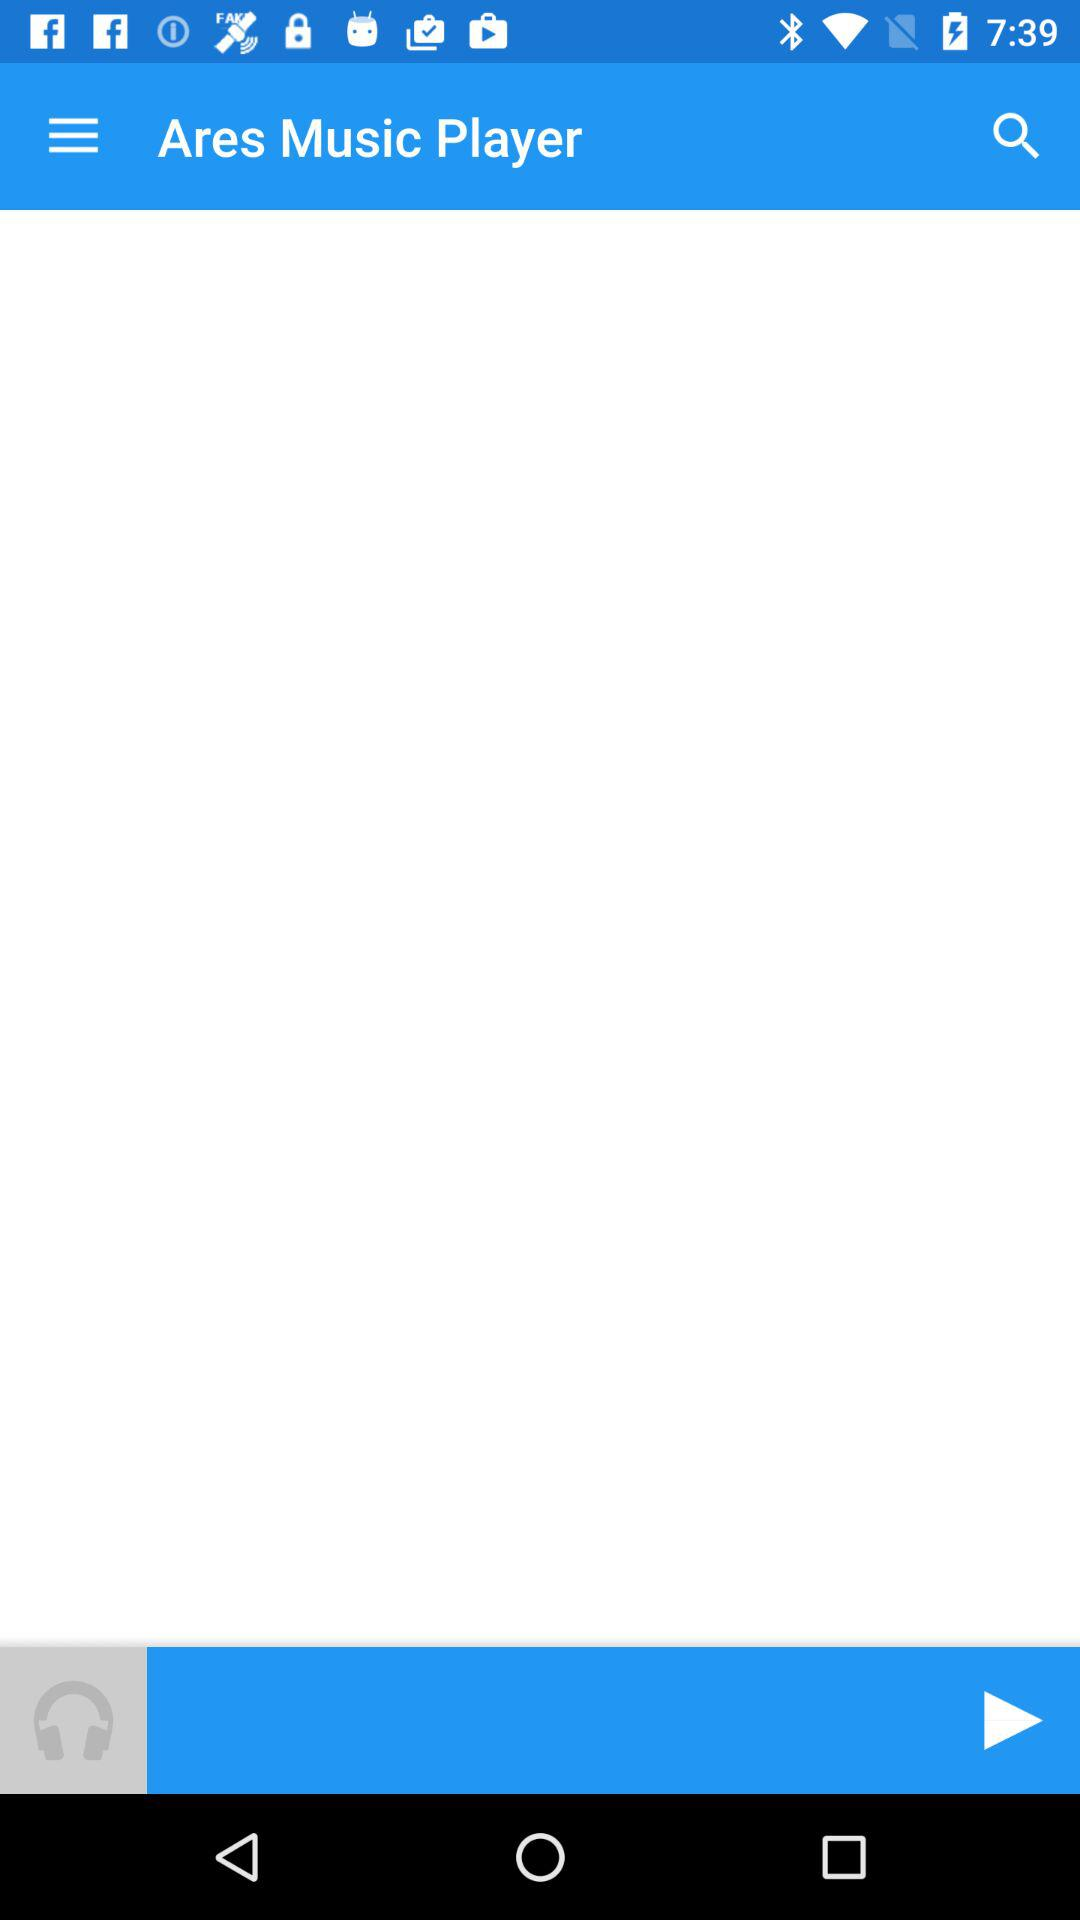What is the name of the music player? The name of the music player is "Ares Music Player". 